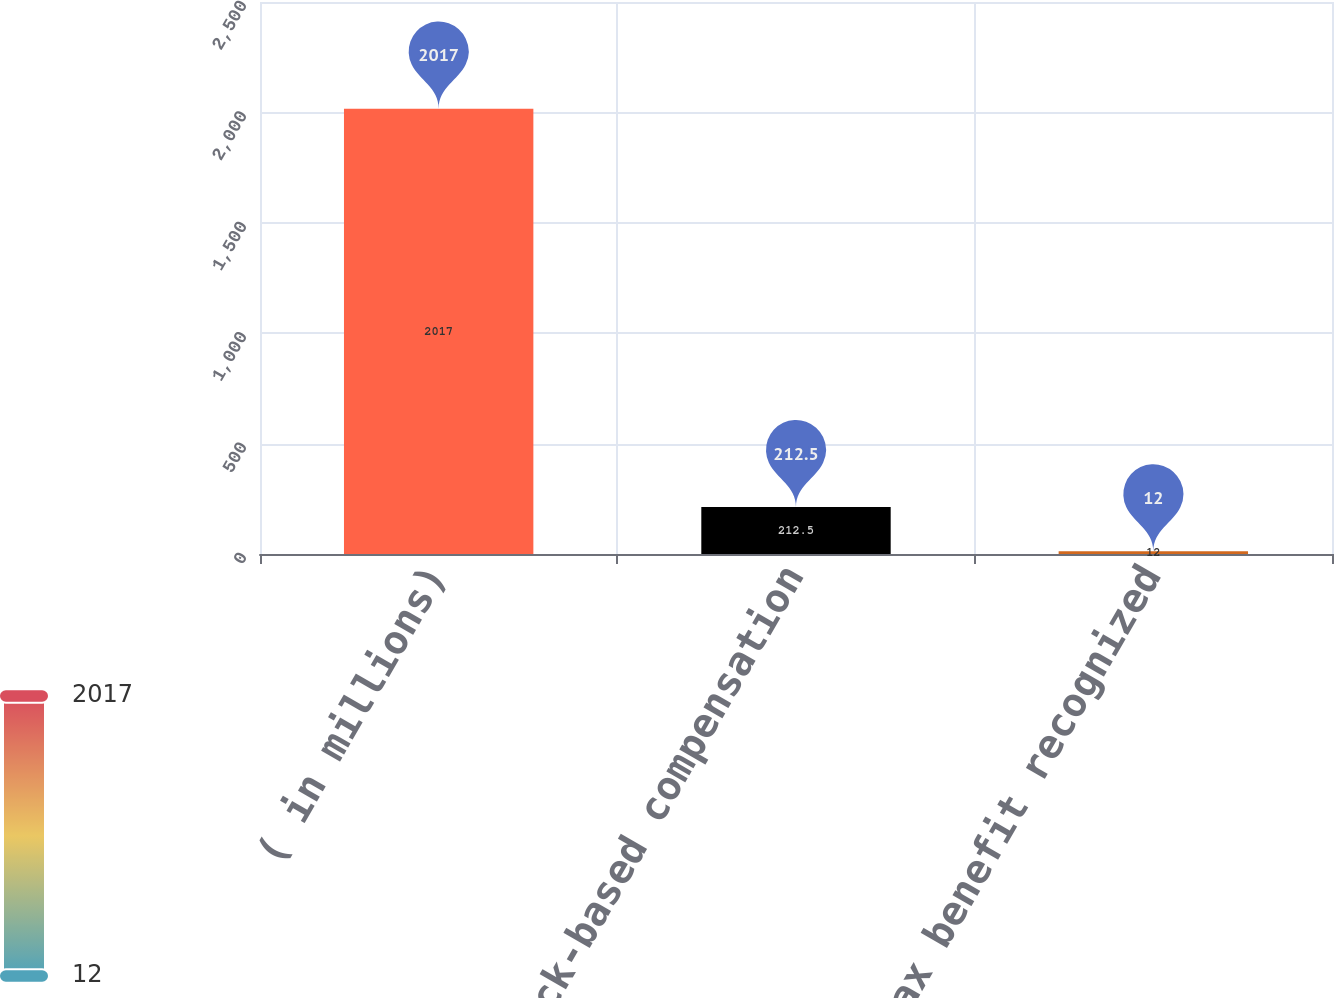<chart> <loc_0><loc_0><loc_500><loc_500><bar_chart><fcel>( in millions)<fcel>Total stock-based compensation<fcel>Income tax benefit recognized<nl><fcel>2017<fcel>212.5<fcel>12<nl></chart> 